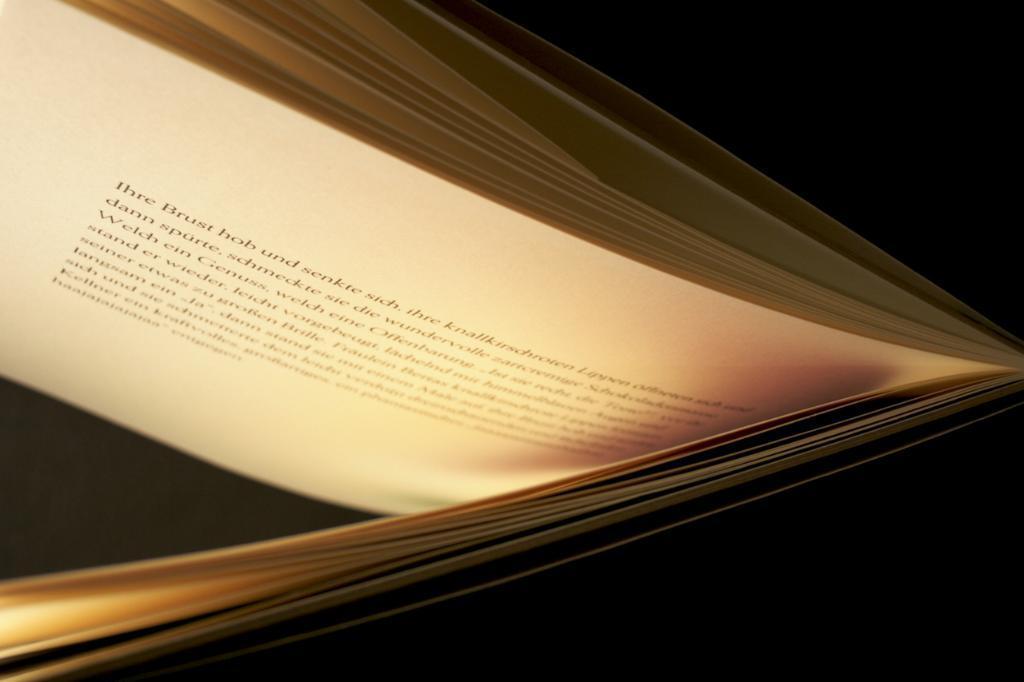In one or two sentences, can you explain what this image depicts? In this picture we can see the book in which some words are written. 